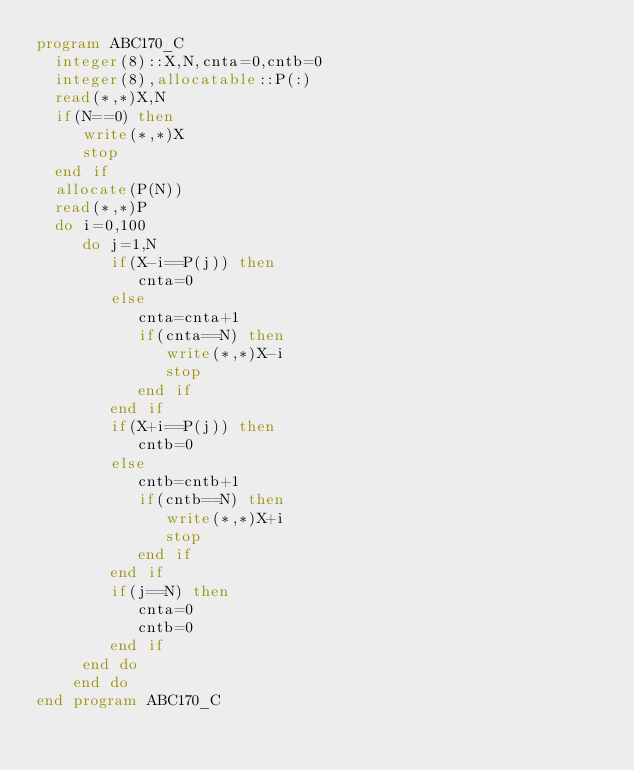Convert code to text. <code><loc_0><loc_0><loc_500><loc_500><_FORTRAN_>program ABC170_C
  integer(8)::X,N,cnta=0,cntb=0
  integer(8),allocatable::P(:)
  read(*,*)X,N
  if(N==0) then
     write(*,*)X
     stop
  end if
  allocate(P(N))
  read(*,*)P
  do i=0,100
     do j=1,N
        if(X-i==P(j)) then
           cnta=0
        else
           cnta=cnta+1
           if(cnta==N) then
              write(*,*)X-i
              stop
           end if
        end if
        if(X+i==P(j)) then
           cntb=0
        else
           cntb=cntb+1
           if(cntb==N) then
              write(*,*)X+i
              stop
           end if
        end if
        if(j==N) then
           cnta=0
           cntb=0
        end if
     end do
    end do
end program ABC170_C</code> 